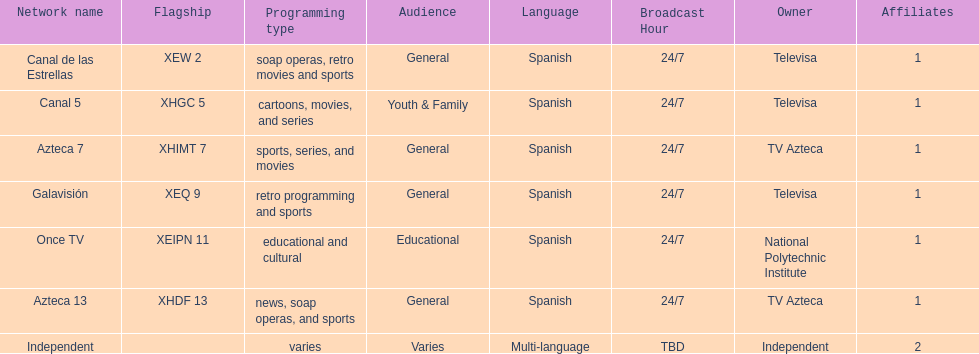How many networks does televisa own? 3. 